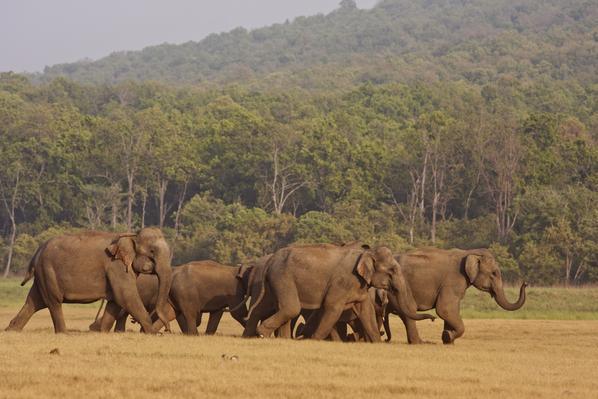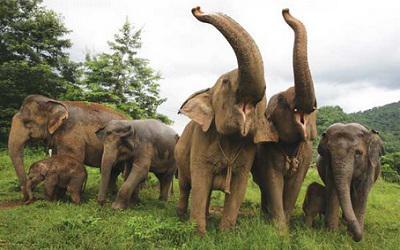The first image is the image on the left, the second image is the image on the right. Examine the images to the left and right. Is the description "An image shows one or more adult elephants with trunk raised at least head-high." accurate? Answer yes or no. Yes. 